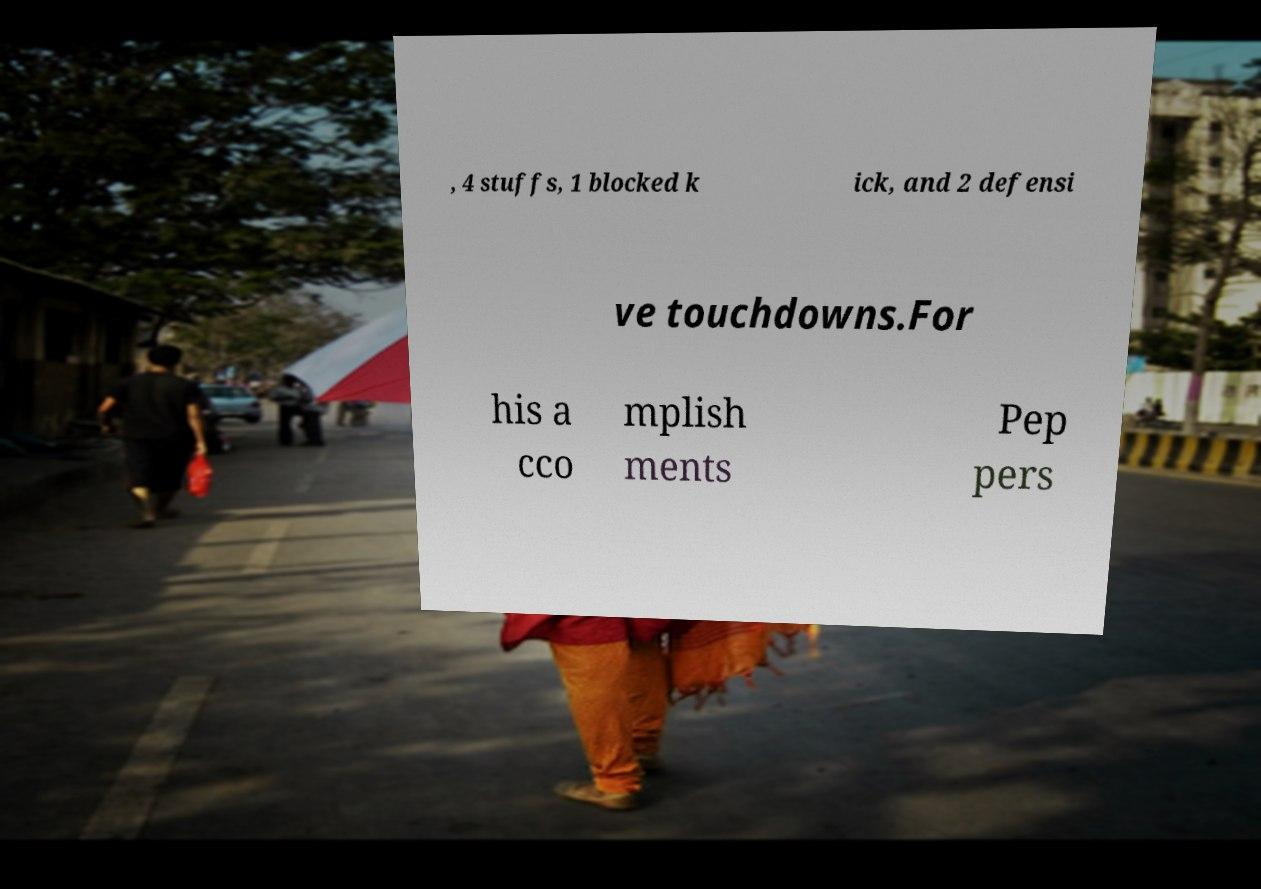For documentation purposes, I need the text within this image transcribed. Could you provide that? , 4 stuffs, 1 blocked k ick, and 2 defensi ve touchdowns.For his a cco mplish ments Pep pers 